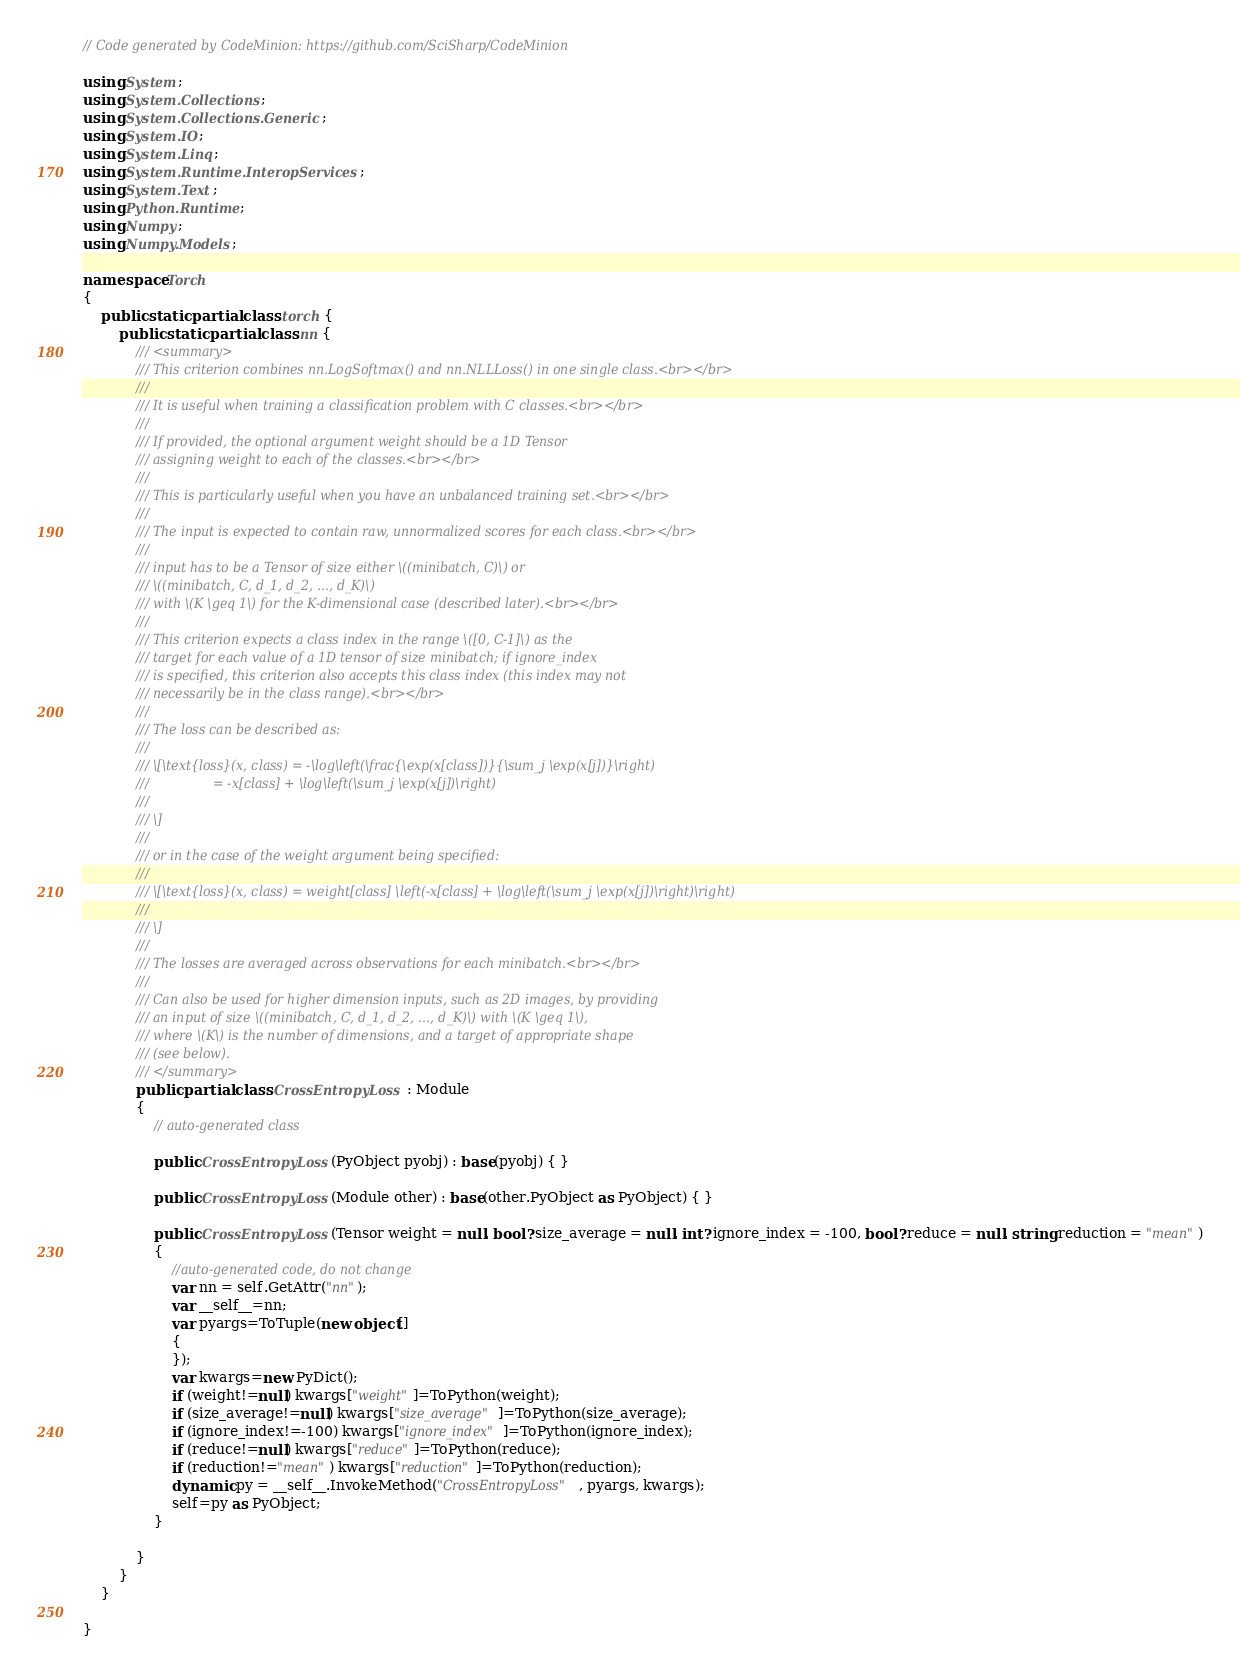<code> <loc_0><loc_0><loc_500><loc_500><_C#_>// Code generated by CodeMinion: https://github.com/SciSharp/CodeMinion

using System;
using System.Collections;
using System.Collections.Generic;
using System.IO;
using System.Linq;
using System.Runtime.InteropServices;
using System.Text;
using Python.Runtime;
using Numpy;
using Numpy.Models;

namespace Torch
{
    public static partial class torch {
        public static partial class nn {
            /// <summary>
            ///	This criterion combines nn.LogSoftmax() and nn.NLLLoss() in one single class.<br></br>
            ///	
            ///	It is useful when training a classification problem with C classes.<br></br>
            ///	
            ///	If provided, the optional argument weight should be a 1D Tensor
            ///	assigning weight to each of the classes.<br></br>
            ///	
            ///	This is particularly useful when you have an unbalanced training set.<br></br>
            ///	
            ///	The input is expected to contain raw, unnormalized scores for each class.<br></br>
            ///	
            ///	input has to be a Tensor of size either \((minibatch, C)\) or
            ///	\((minibatch, C, d_1, d_2, ..., d_K)\)
            ///	with \(K \geq 1\) for the K-dimensional case (described later).<br></br>
            ///	
            ///	This criterion expects a class index in the range \([0, C-1]\) as the
            ///	target for each value of a 1D tensor of size minibatch; if ignore_index
            ///	is specified, this criterion also accepts this class index (this index may not
            ///	necessarily be in the class range).<br></br>
            ///	
            ///	The loss can be described as:
            ///	
            ///	\[\text{loss}(x, class) = -\log\left(\frac{\exp(x[class])}{\sum_j \exp(x[j])}\right)
            ///	               = -x[class] + \log\left(\sum_j \exp(x[j])\right)
            ///	
            ///	\]
            ///	
            ///	or in the case of the weight argument being specified:
            ///	
            ///	\[\text{loss}(x, class) = weight[class] \left(-x[class] + \log\left(\sum_j \exp(x[j])\right)\right)
            ///	
            ///	\]
            ///	
            ///	The losses are averaged across observations for each minibatch.<br></br>
            ///	
            ///	Can also be used for higher dimension inputs, such as 2D images, by providing
            ///	an input of size \((minibatch, C, d_1, d_2, ..., d_K)\) with \(K \geq 1\),
            ///	where \(K\) is the number of dimensions, and a target of appropriate shape
            ///	(see below).
            /// </summary>
            public partial class CrossEntropyLoss : Module
            {
                // auto-generated class
                
                public CrossEntropyLoss(PyObject pyobj) : base(pyobj) { }
                
                public CrossEntropyLoss(Module other) : base(other.PyObject as PyObject) { }
                
                public CrossEntropyLoss(Tensor weight = null, bool? size_average = null, int? ignore_index = -100, bool? reduce = null, string reduction = "mean")
                {
                    //auto-generated code, do not change
                    var nn = self.GetAttr("nn");
                    var __self__=nn;
                    var pyargs=ToTuple(new object[]
                    {
                    });
                    var kwargs=new PyDict();
                    if (weight!=null) kwargs["weight"]=ToPython(weight);
                    if (size_average!=null) kwargs["size_average"]=ToPython(size_average);
                    if (ignore_index!=-100) kwargs["ignore_index"]=ToPython(ignore_index);
                    if (reduce!=null) kwargs["reduce"]=ToPython(reduce);
                    if (reduction!="mean") kwargs["reduction"]=ToPython(reduction);
                    dynamic py = __self__.InvokeMethod("CrossEntropyLoss", pyargs, kwargs);
                    self=py as PyObject;
                }
                
            }
        }
    }
    
}
</code> 